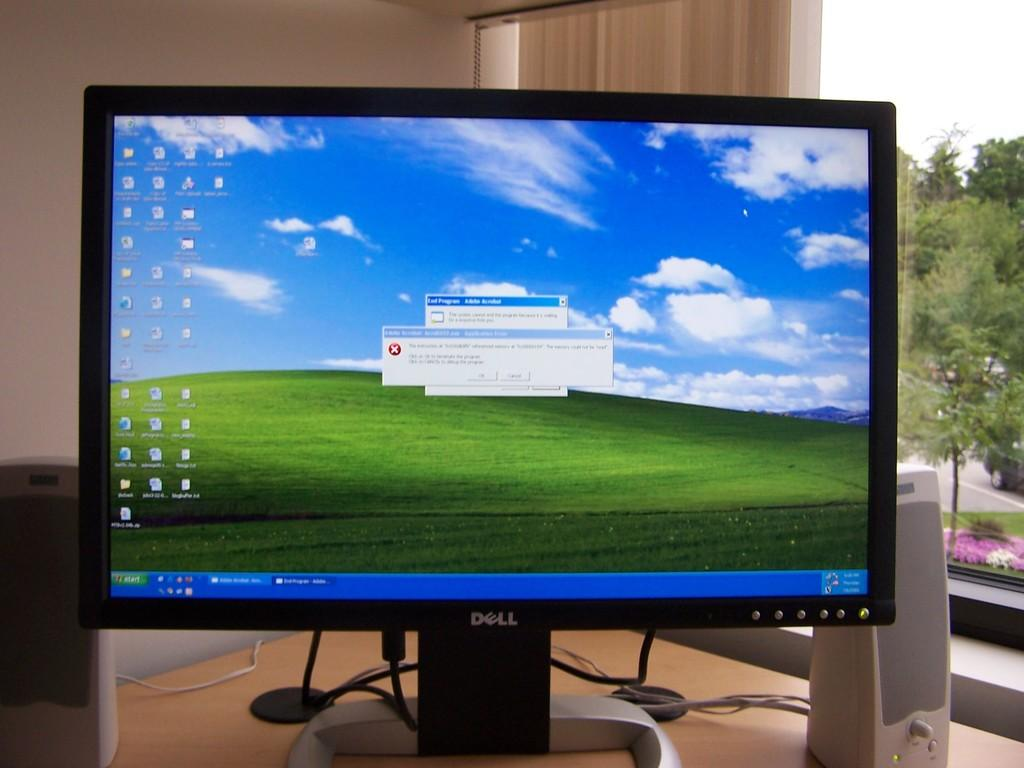<image>
Render a clear and concise summary of the photo. A dell computer monitor with a red x on the screen noting an error in a windows application 